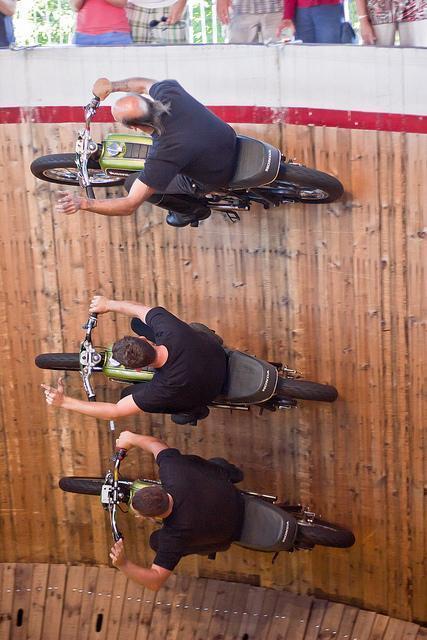How many motorcycles are in the photo?
Give a very brief answer. 3. How many people can be seen?
Give a very brief answer. 8. 